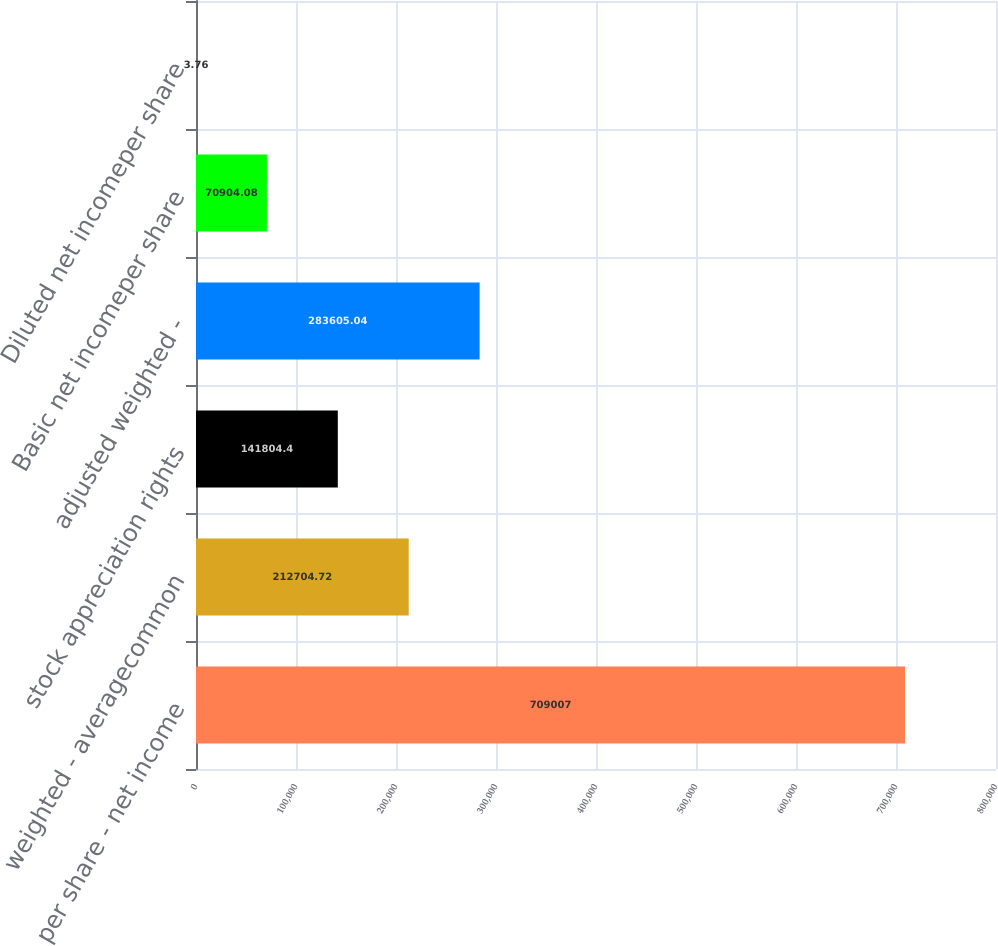Convert chart to OTSL. <chart><loc_0><loc_0><loc_500><loc_500><bar_chart><fcel>per share - net income<fcel>weighted - averagecommon<fcel>stock appreciation rights<fcel>adjusted weighted -<fcel>Basic net incomeper share<fcel>Diluted net incomeper share<nl><fcel>709007<fcel>212705<fcel>141804<fcel>283605<fcel>70904.1<fcel>3.76<nl></chart> 